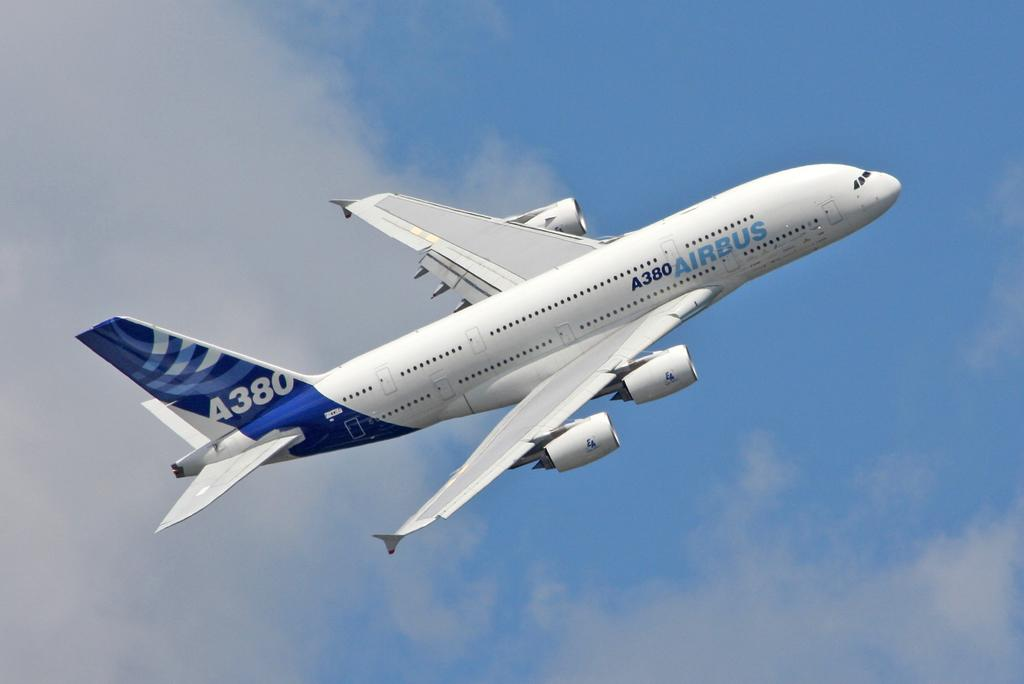<image>
Describe the image concisely. A white plane has a blue tail with the identification of A380. 